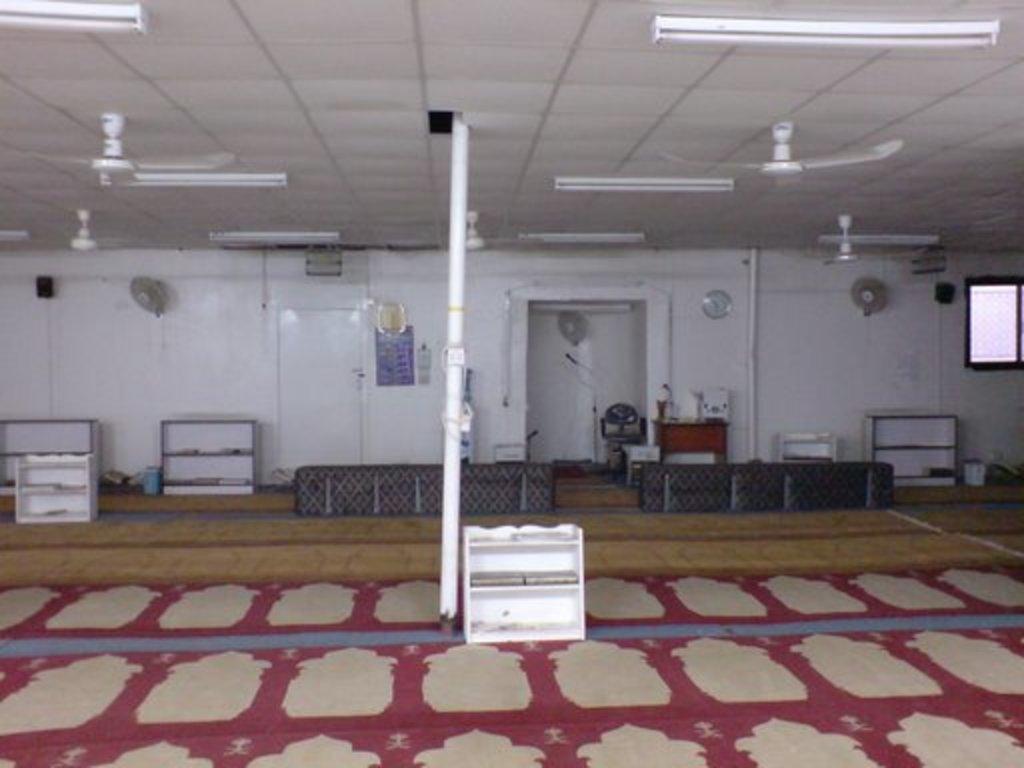How would you summarize this image in a sentence or two? Here in this picture we can see a pole present in the middle and we can see some racks present in the room and we can also see lights and fans present on the roof and in the middle we can see some benches present and we can also see a table with somethings present over there and we can see a door present on the left side and on the right side we can see a digital monitor also present. 